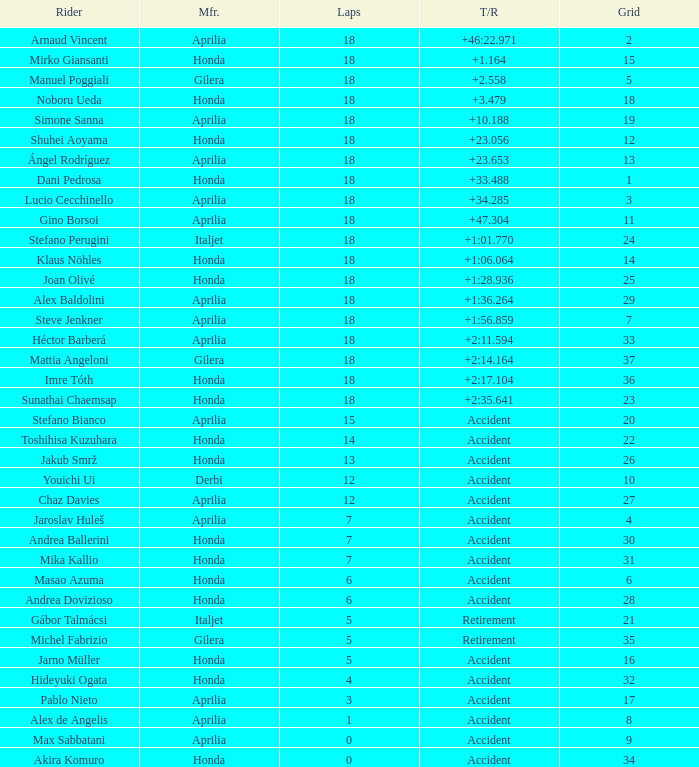What is the average number of laps with an accident time/retired, aprilia manufacturer and a grid of 27? 12.0. Would you mind parsing the complete table? {'header': ['Rider', 'Mfr.', 'Laps', 'T/R', 'Grid'], 'rows': [['Arnaud Vincent', 'Aprilia', '18', '+46:22.971', '2'], ['Mirko Giansanti', 'Honda', '18', '+1.164', '15'], ['Manuel Poggiali', 'Gilera', '18', '+2.558', '5'], ['Noboru Ueda', 'Honda', '18', '+3.479', '18'], ['Simone Sanna', 'Aprilia', '18', '+10.188', '19'], ['Shuhei Aoyama', 'Honda', '18', '+23.056', '12'], ['Ángel Rodríguez', 'Aprilia', '18', '+23.653', '13'], ['Dani Pedrosa', 'Honda', '18', '+33.488', '1'], ['Lucio Cecchinello', 'Aprilia', '18', '+34.285', '3'], ['Gino Borsoi', 'Aprilia', '18', '+47.304', '11'], ['Stefano Perugini', 'Italjet', '18', '+1:01.770', '24'], ['Klaus Nöhles', 'Honda', '18', '+1:06.064', '14'], ['Joan Olivé', 'Honda', '18', '+1:28.936', '25'], ['Alex Baldolini', 'Aprilia', '18', '+1:36.264', '29'], ['Steve Jenkner', 'Aprilia', '18', '+1:56.859', '7'], ['Héctor Barberá', 'Aprilia', '18', '+2:11.594', '33'], ['Mattia Angeloni', 'Gilera', '18', '+2:14.164', '37'], ['Imre Tóth', 'Honda', '18', '+2:17.104', '36'], ['Sunathai Chaemsap', 'Honda', '18', '+2:35.641', '23'], ['Stefano Bianco', 'Aprilia', '15', 'Accident', '20'], ['Toshihisa Kuzuhara', 'Honda', '14', 'Accident', '22'], ['Jakub Smrž', 'Honda', '13', 'Accident', '26'], ['Youichi Ui', 'Derbi', '12', 'Accident', '10'], ['Chaz Davies', 'Aprilia', '12', 'Accident', '27'], ['Jaroslav Huleš', 'Aprilia', '7', 'Accident', '4'], ['Andrea Ballerini', 'Honda', '7', 'Accident', '30'], ['Mika Kallio', 'Honda', '7', 'Accident', '31'], ['Masao Azuma', 'Honda', '6', 'Accident', '6'], ['Andrea Dovizioso', 'Honda', '6', 'Accident', '28'], ['Gábor Talmácsi', 'Italjet', '5', 'Retirement', '21'], ['Michel Fabrizio', 'Gilera', '5', 'Retirement', '35'], ['Jarno Müller', 'Honda', '5', 'Accident', '16'], ['Hideyuki Ogata', 'Honda', '4', 'Accident', '32'], ['Pablo Nieto', 'Aprilia', '3', 'Accident', '17'], ['Alex de Angelis', 'Aprilia', '1', 'Accident', '8'], ['Max Sabbatani', 'Aprilia', '0', 'Accident', '9'], ['Akira Komuro', 'Honda', '0', 'Accident', '34']]} 